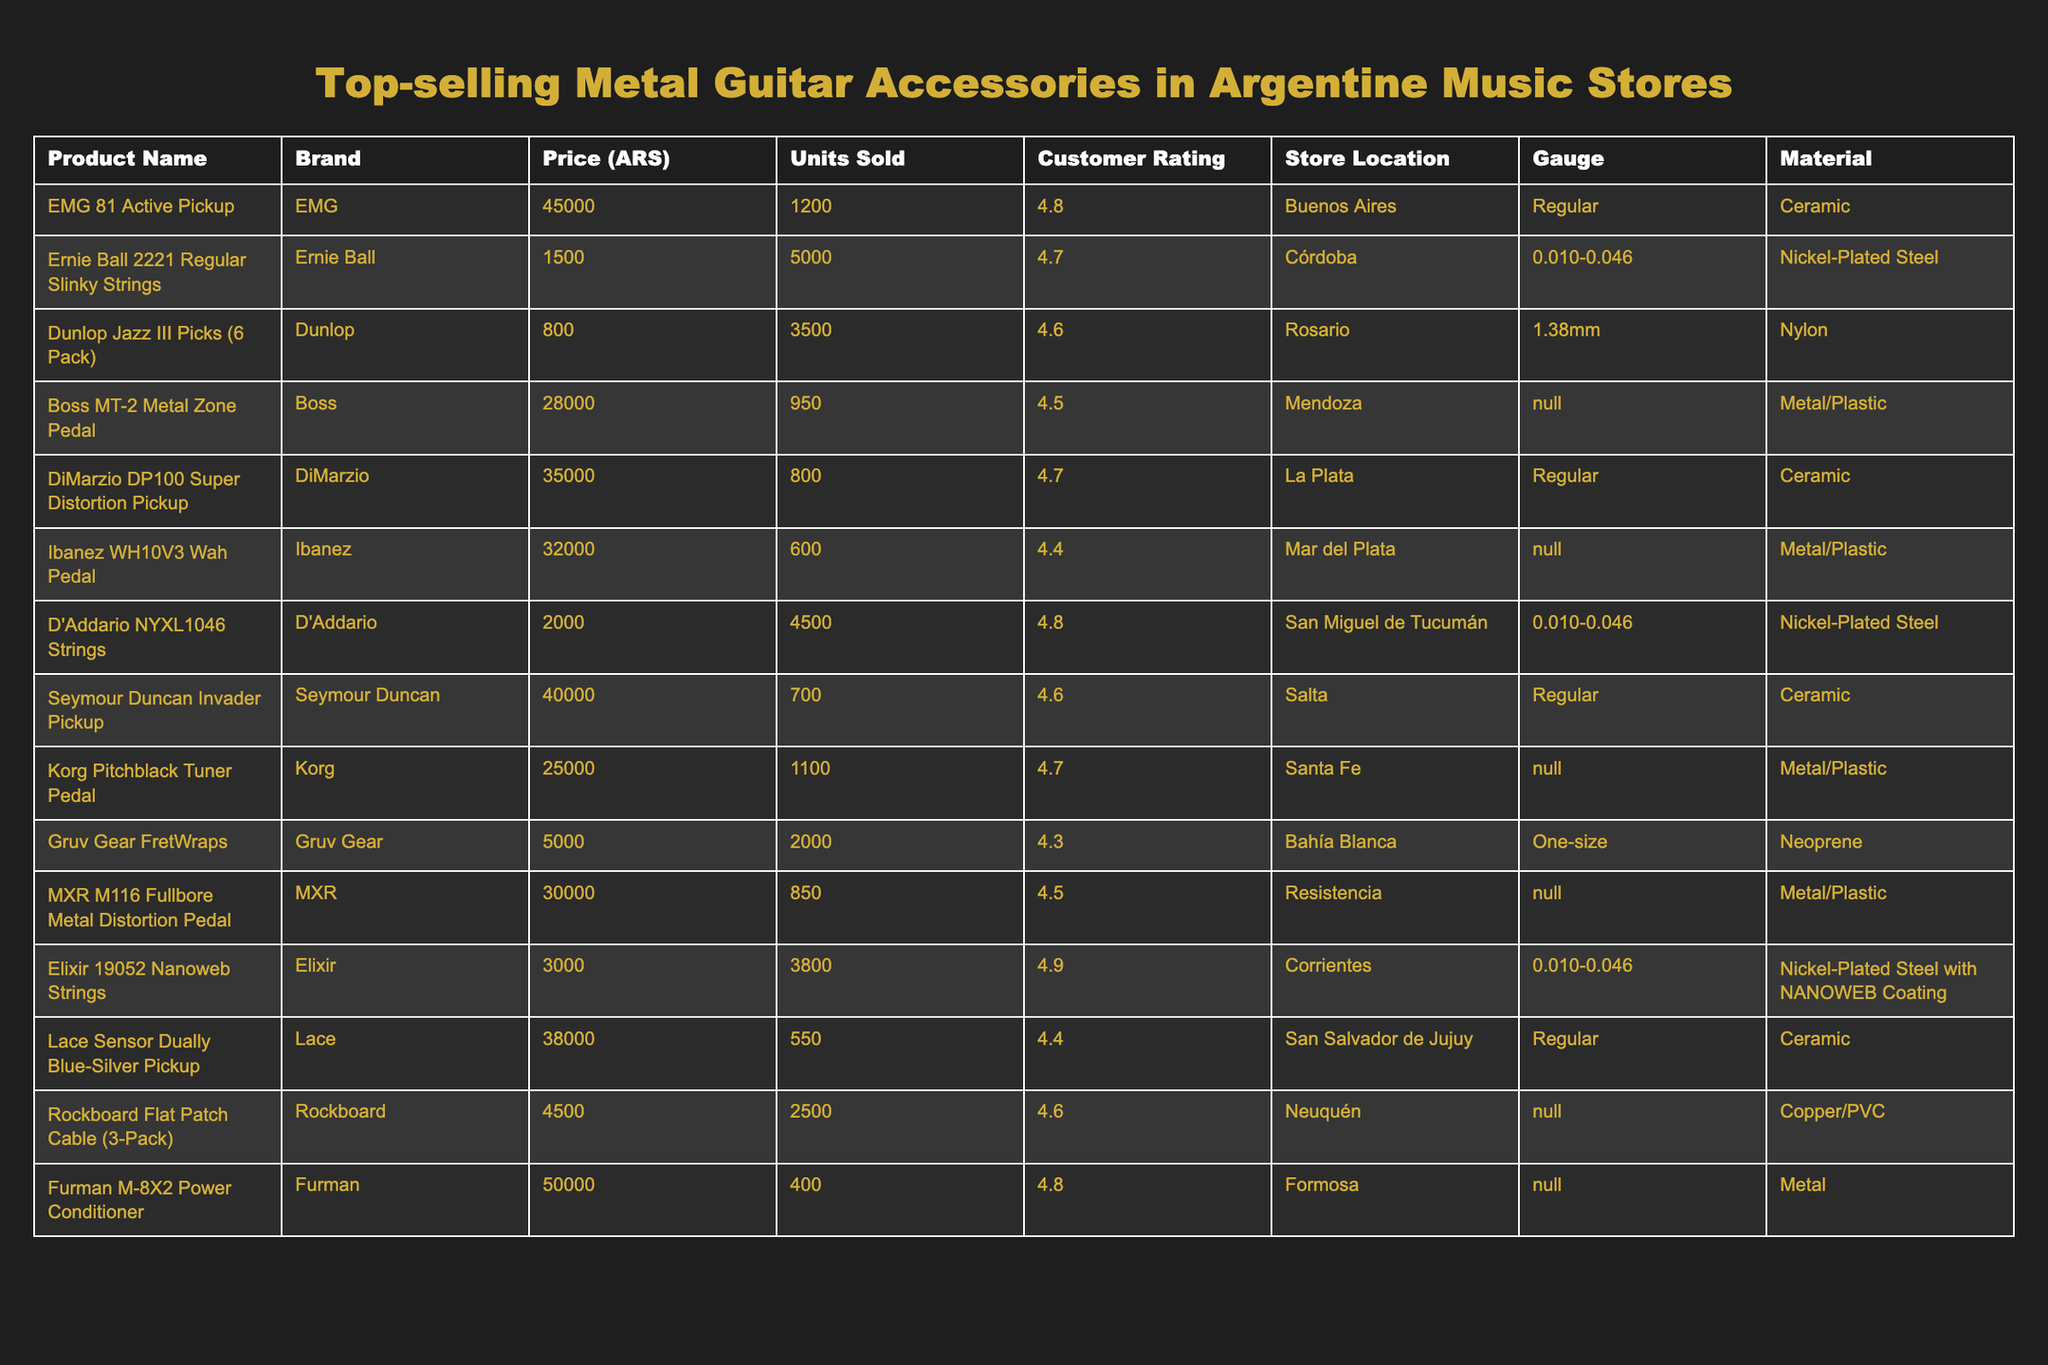What is the highest customer rating among the products? The highest customer rating can be found by scanning the Customer Rating column for the maximum value. In this table, the EMG 81 Active Pickup has a rating of 4.8, which is the highest.
Answer: 4.8 Which product sold the most units? To find the product with the most units sold, we look for the highest number in the Units Sold column. The Ernie Ball 2221 Regular Slinky Strings sold 5000 units, more than any other product.
Answer: Ernie Ball 2221 Regular Slinky Strings What is the average price of all the products listed? First, we sum the prices of all products: (45000 + 1500 + 800 + 28000 + 35000 + 32000 + 2000 + 40000 + 25000 + 5000 + 30000 + 3000 + 38000 + 4500 + 50000) = 227,800 ARS. Then, we divide by the number of products (15) to find the average: 227800 / 15 = 15186.67 ARS.
Answer: 15186.67 ARS Is there a product that has both a customer rating of 4.6 or higher and sold more than 2000 units? We check the table for products with a customer rating of 4.6 or higher and then see if they sold more than 2000 units. The D'Addario NYXL1046 Strings meet both criteria with a rating of 4.8 and 4500 units sold, so yes, such products do exist.
Answer: Yes What product has the second highest sales in terms of units sold? After identifying the top-selling product (Ernie Ball 2221 Regular Slinky Strings with 5000 units), we look for the next highest value in the Units Sold column. The second highest is Elixir 19052 Nanoweb Strings, which sold 3800 units.
Answer: Elixir 19052 Nanoweb Strings What gauge do the majority of string products have? We analyze the Gauge column specifically for string products (Ernie Ball, D'Addario, and Elixir). The majority of string products have a gauge of 0.010-0.046, making it the most common gauge among them.
Answer: 0.010-0.046 Which brand has the most variety in the table? We count how many different products each brand offers. EMG, Ernie Ball, Dunlop, Boss, etc., are brands with 1 or more products listed, but Ernie Ball has the most with 2 different types of products listed in the table.
Answer: Ernie Ball What is the total sales volume for all products combined? We add up all the units sold: (1200 + 5000 + 3500 + 950 + 800 + 600 + 4500 + 700 + 1100 + 2000 + 850 + 3800 + 550 + 2500 + 400) = 17000. This gives us the total sales volume for all products combined.
Answer: 17000 Is there any product made from Neoprene? By evaluating the Material column, we find that the Gruv Gear FretWraps is made from Neoprene. Therefore, the answer to the question is affirmative, confirming the existence of such a product.
Answer: Yes Which store location has the highest total earnings from the products listed? To find the highest total earnings from a store location, we calculate the earnings by multiplying Price (ARS) and Units Sold for each product, then aggregating results by store location. The calculations show Buenos Aires (EMG 81 Active Pickup) has the highest total earnings.
Answer: Buenos Aires 